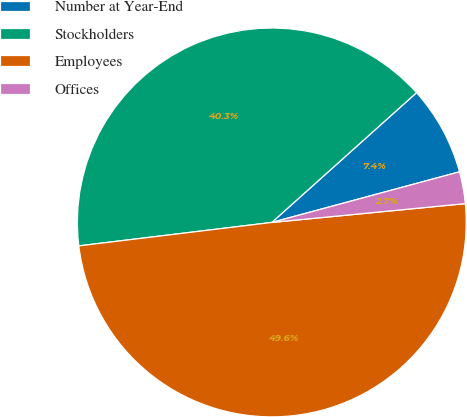Convert chart. <chart><loc_0><loc_0><loc_500><loc_500><pie_chart><fcel>Number at Year-End<fcel>Stockholders<fcel>Employees<fcel>Offices<nl><fcel>7.44%<fcel>40.29%<fcel>49.62%<fcel>2.65%<nl></chart> 